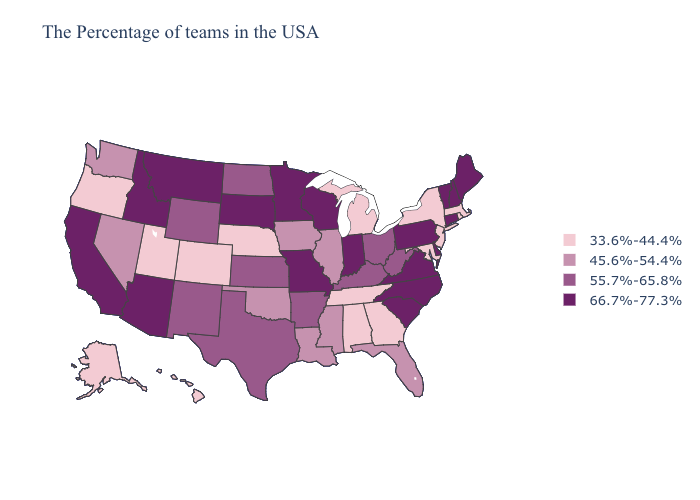Among the states that border Mississippi , does Tennessee have the lowest value?
Keep it brief. Yes. Does the map have missing data?
Short answer required. No. Does Arkansas have a higher value than Wyoming?
Answer briefly. No. Among the states that border Idaho , which have the highest value?
Answer briefly. Montana. What is the value of Mississippi?
Quick response, please. 45.6%-54.4%. Is the legend a continuous bar?
Be succinct. No. Name the states that have a value in the range 45.6%-54.4%?
Answer briefly. Florida, Illinois, Mississippi, Louisiana, Iowa, Oklahoma, Nevada, Washington. Does Georgia have the lowest value in the South?
Answer briefly. Yes. Does the first symbol in the legend represent the smallest category?
Give a very brief answer. Yes. What is the value of Mississippi?
Concise answer only. 45.6%-54.4%. What is the highest value in the MidWest ?
Answer briefly. 66.7%-77.3%. What is the value of Connecticut?
Write a very short answer. 66.7%-77.3%. Among the states that border Ohio , which have the highest value?
Quick response, please. Pennsylvania, Indiana. Name the states that have a value in the range 55.7%-65.8%?
Keep it brief. West Virginia, Ohio, Kentucky, Arkansas, Kansas, Texas, North Dakota, Wyoming, New Mexico. Name the states that have a value in the range 66.7%-77.3%?
Write a very short answer. Maine, New Hampshire, Vermont, Connecticut, Delaware, Pennsylvania, Virginia, North Carolina, South Carolina, Indiana, Wisconsin, Missouri, Minnesota, South Dakota, Montana, Arizona, Idaho, California. 